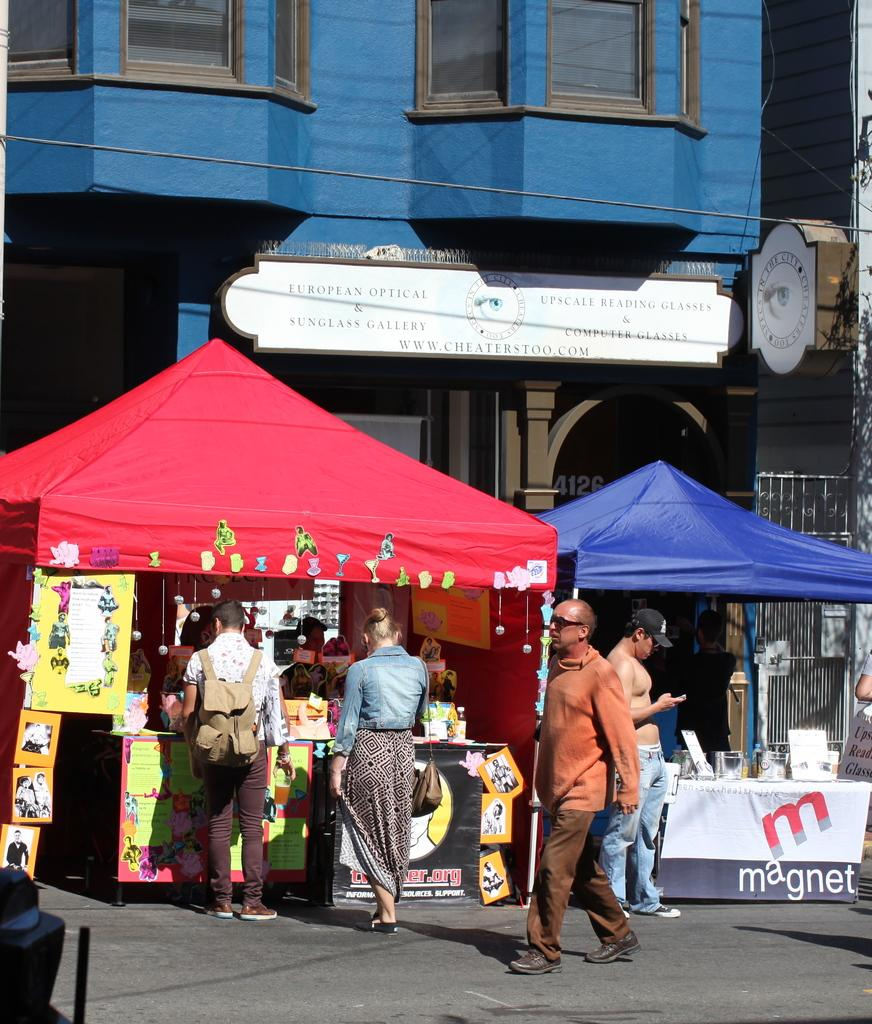What type of structures are present in the image? There are stalls in the image. What can be seen hanging or displayed in the image? There are banners and frames in the image. Who or what is visible in the image? There are people in the image. What can be seen in the distance in the image? There is a building and boards in the background of the image. What type of cactus is growing out of the stick in the image? There is no cactus or stick present in the image. 